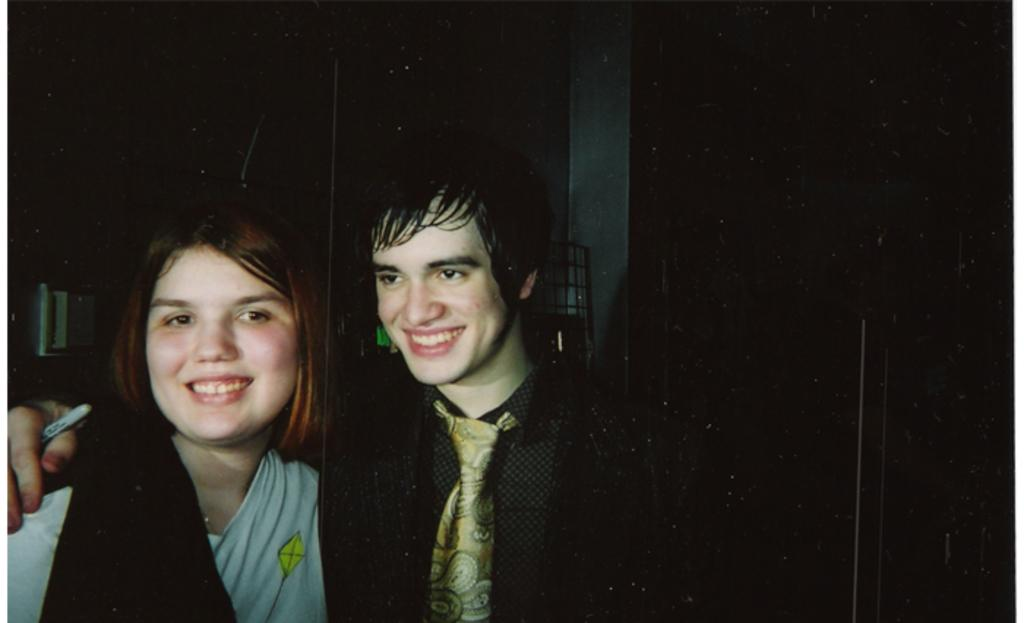How many people are in the image? There are two persons in the image. What is the facial expression of the people in the image? Both persons are smiling. Can you describe the clothing of the person on the right side? The person on the right side is wearing a tie. What is the color of the background in the image? The background of the image is dark. What type of pot can be seen in the library in the image? There is no pot or library present in the image; it features two smiling persons. Can you tell me how many bears are visible in the image? There are no bears visible in the image. 